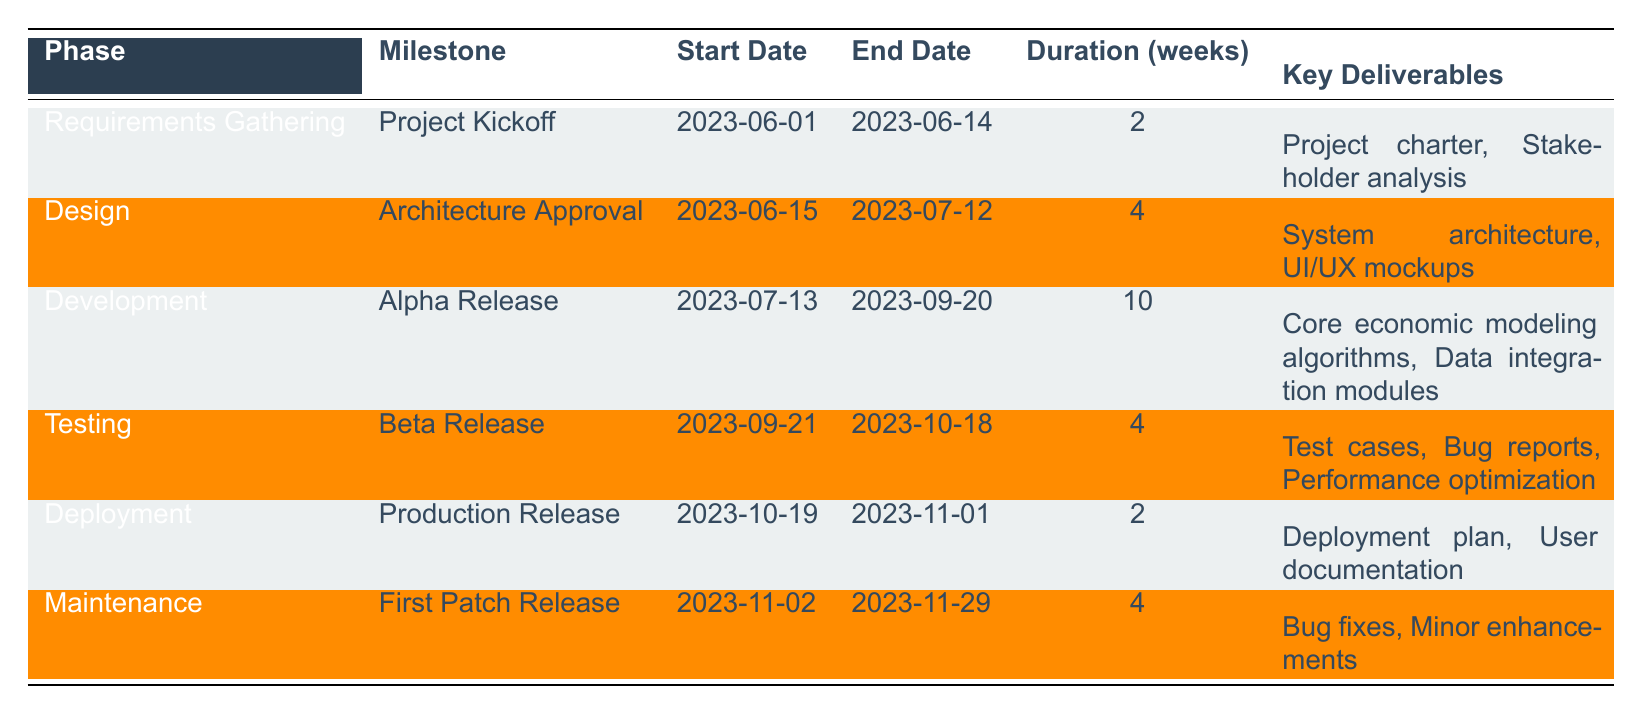What is the duration of the Development phase? The Development phase is listed in the table under the corresponding rows. The duration is stated as 10 weeks.
Answer: 10 weeks Which milestone follows the Alpha Release? By examining the table, the Alpha Release is the milestone in the Development phase, which is followed by the Beta Release in the Testing phase.
Answer: Beta Release What are the key deliverables of the Testing phase? The Testing phase has a milestone called Beta Release, which has the key deliverables listed as Test cases, Bug reports, and Performance optimization.
Answer: Test cases, Bug reports, Performance optimization Is there a milestone that spans more than 10 weeks? The table shows durations for each milestone, and the longest duration is for the Development phase, which is 10 weeks. Therefore, no milestones exceed this duration.
Answer: No What is the total duration of all phases combined? To find the total duration, add the individual durations: 2 (Requirements Gathering) + 4 (Design) + 10 (Development) + 4 (Testing) + 2 (Deployment) + 4 (Maintenance) = 26 weeks.
Answer: 26 weeks How many key deliverables are associated with the Deployment phase? The Deployment phase has one milestone, which is Production Release. It has two key deliverables: Deployment plan and User documentation, thus totaling two deliverables.
Answer: 2 During which phase is the Project Kickoff milestone scheduled? The table indicates that Project Kickoff is under the Requirements Gathering phase.
Answer: Requirements Gathering Which milestone has the earliest start date? The start dates are: Project Kickoff (2023-06-01), Architecture Approval (2023-06-15), Alpha Release (2023-07-13), Beta Release (2023-09-21), Production Release (2023-10-19), and First Patch Release (2023-11-02). The earliest is Project Kickoff.
Answer: Project Kickoff 